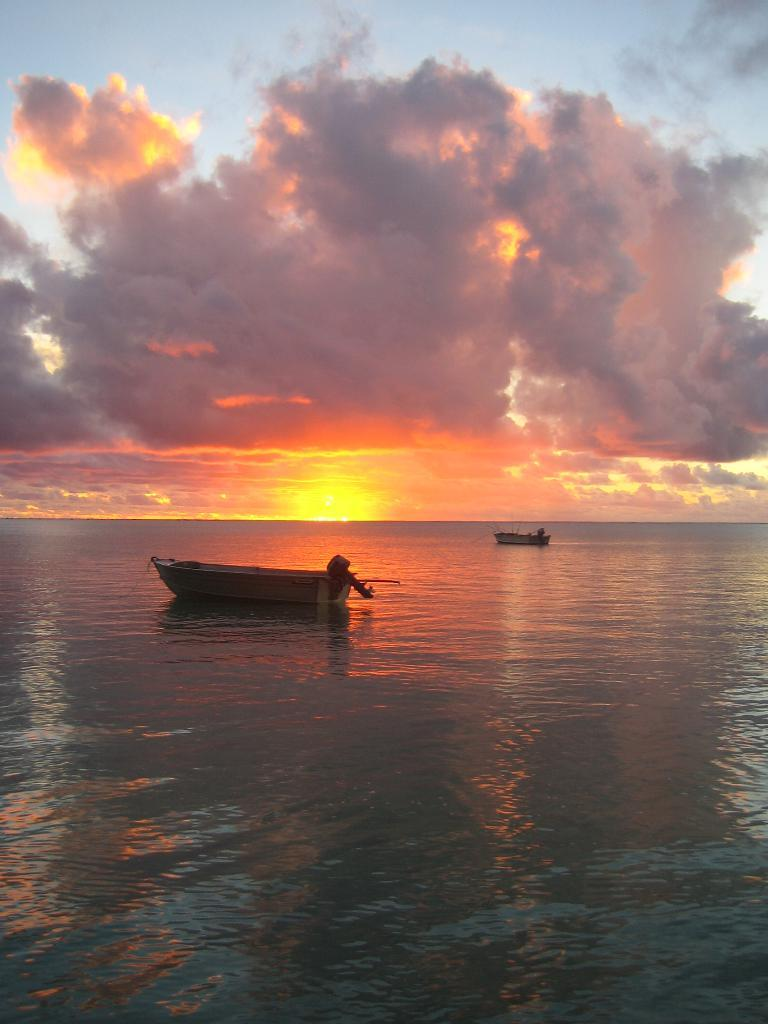How many boats are in the image? There are two boats in the image. Where are the boats located? The boats are on the water. What time of day does the image appear to depict? The image appears to depict a sunset. What type of scarf is being used by the boats in the image? There is no scarf present in the image, as boats do not wear scarves. What emotion might the boats be experiencing during the sunset? Boats do not experience emotions, so it is not possible to determine their emotional state. 